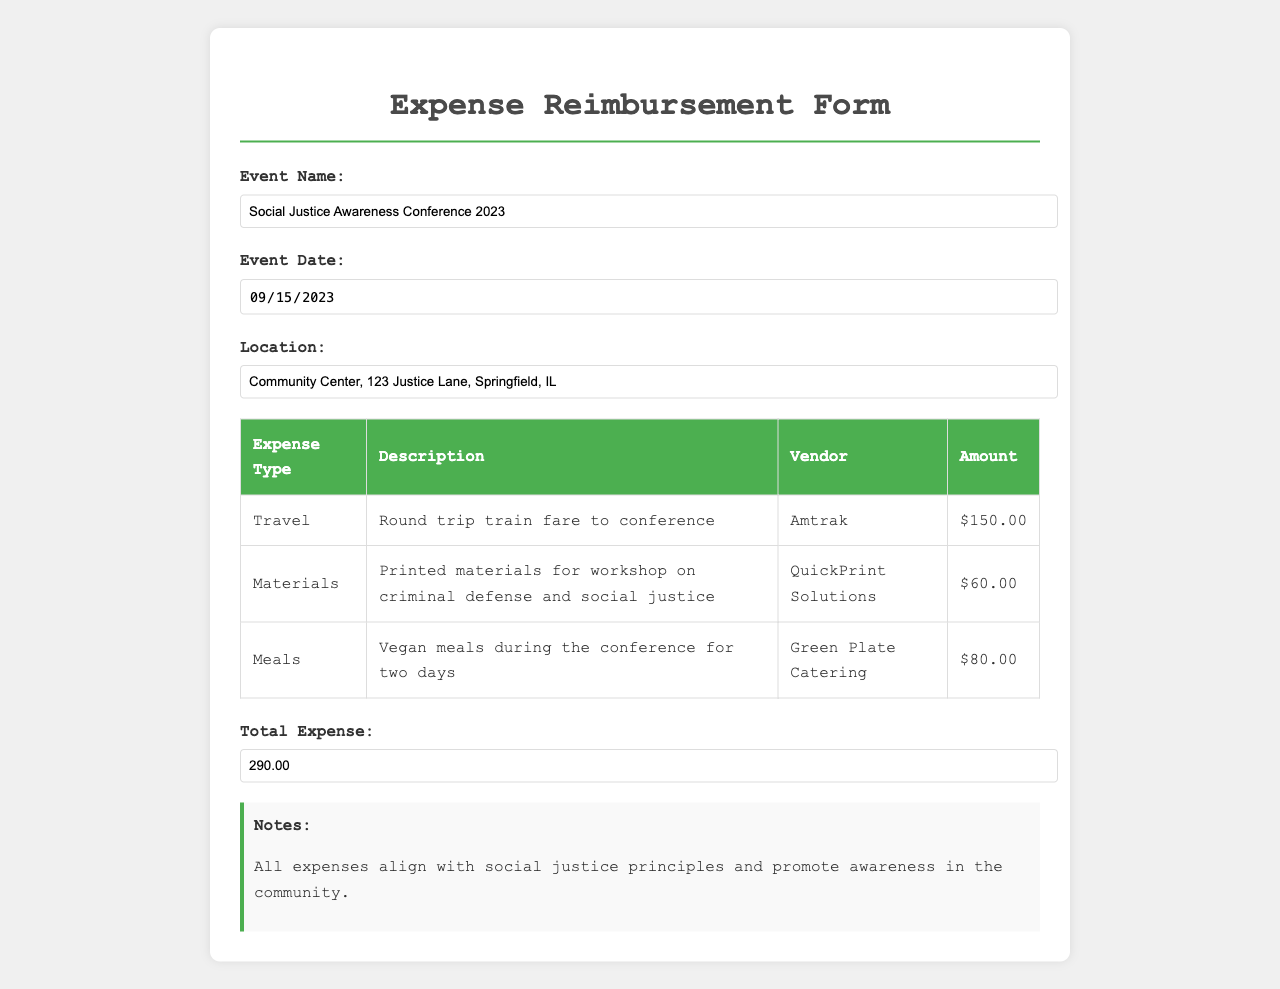What is the event name? The document lists the event name as "Social Justice Awareness Conference 2023".
Answer: Social Justice Awareness Conference 2023 What is the total expense reported? The total expense is explicitly mentioned in the document as $290.00.
Answer: $290.00 What date was the event held? The event date is provided as "2023-09-15" in the document.
Answer: 2023-09-15 What vendor provided the vegan meals? The vendor for the meals is stated as "Green Plate Catering".
Answer: Green Plate Catering How much was spent on printed materials? The document specifies that $60.00 was spent on printed materials.
Answer: $60.00 What type of travel expense was incurred? The document indicates that the travel expense was for a "Round trip train fare to conference".
Answer: Round trip train fare to conference What is the location of the event? The location is detailed as "Community Center, 123 Justice Lane, Springfield, IL".
Answer: Community Center, 123 Justice Lane, Springfield, IL How many days were vegan meals provided? The document mentions that vegan meals were provided during "two days" of the conference.
Answer: two days What is noted in the document regarding expenses? The document notes that all expenses align with social justice principles.
Answer: align with social justice principles 